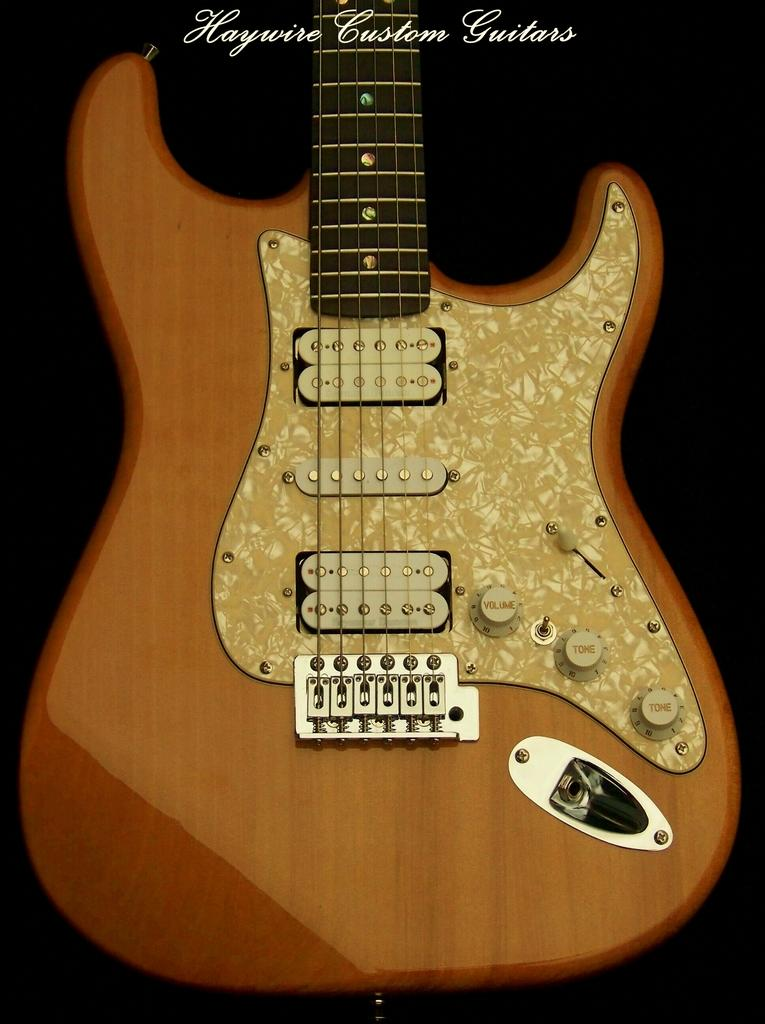What musical instrument is present in the image? There is a guitar in the image. What is written above the guitar in the image? The words "Haywire Custom Guitars" are written above the guitar. What advice is given by the guitar in the image? The guitar in the image is an inanimate object and cannot give advice. 